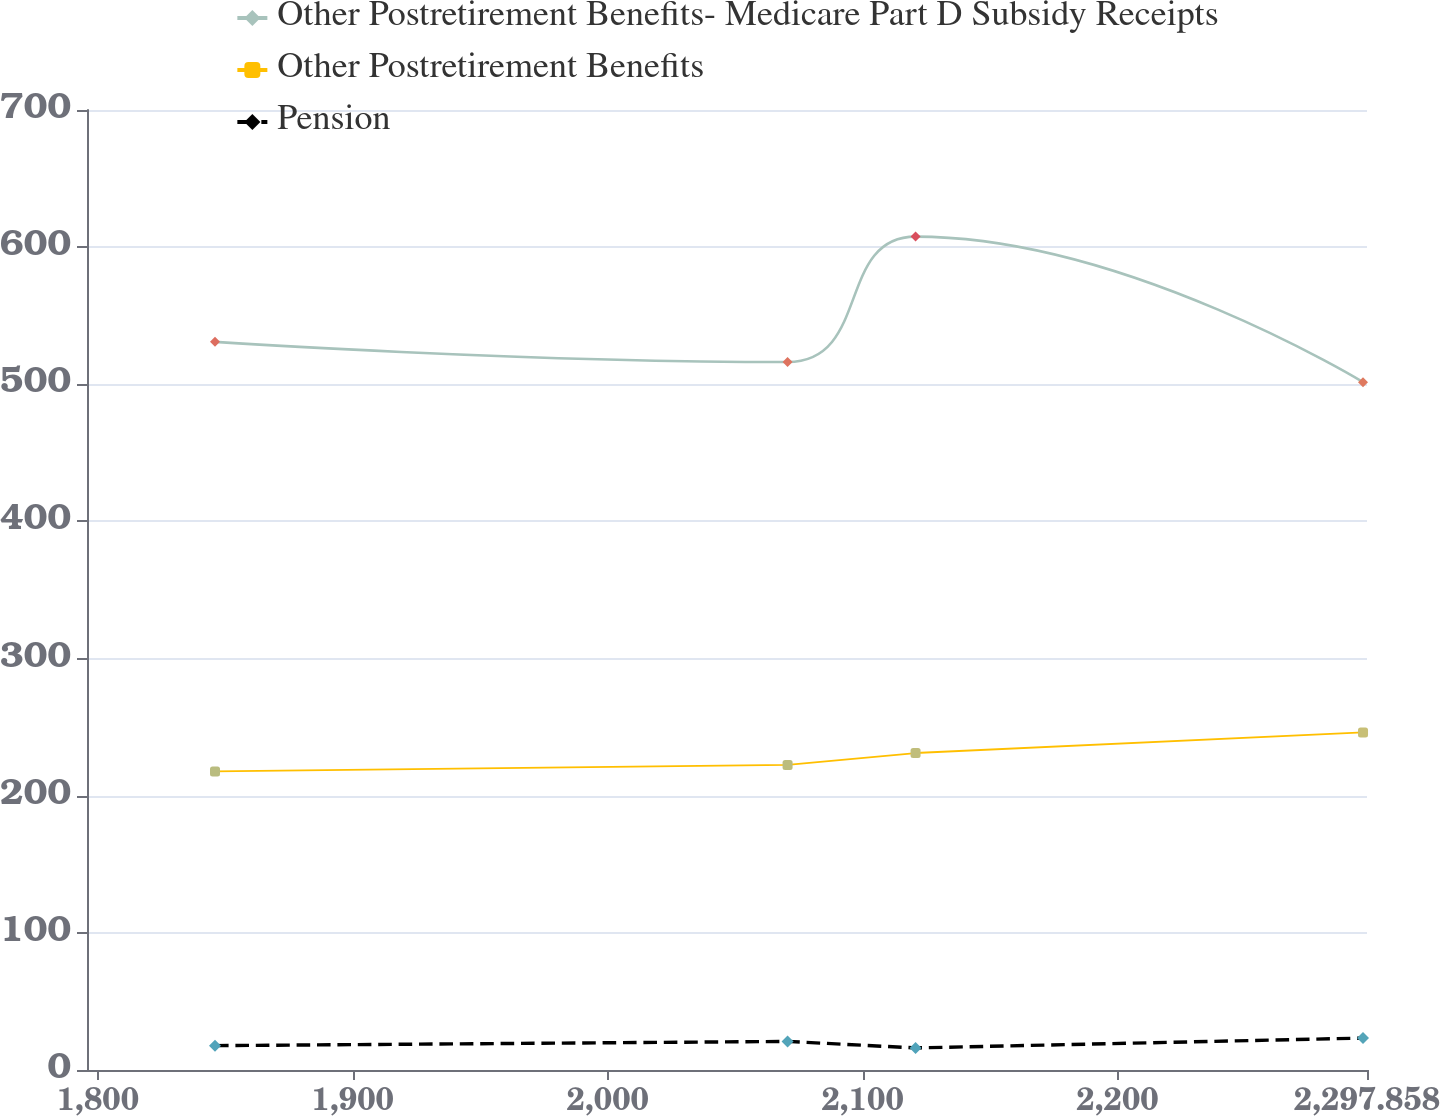Convert chart to OTSL. <chart><loc_0><loc_0><loc_500><loc_500><line_chart><ecel><fcel>Other Postretirement Benefits- Medicare Part D Subsidy Receipts<fcel>Other Postretirement Benefits<fcel>Pension<nl><fcel>1845.95<fcel>530.94<fcel>217.71<fcel>17.76<nl><fcel>2070.56<fcel>516.24<fcel>222.46<fcel>20.84<nl><fcel>2120.77<fcel>607.67<fcel>231.13<fcel>16.09<nl><fcel>2296.3<fcel>501.54<fcel>246.12<fcel>23.29<nl><fcel>2348.07<fcel>460.7<fcel>198.66<fcel>24.79<nl></chart> 